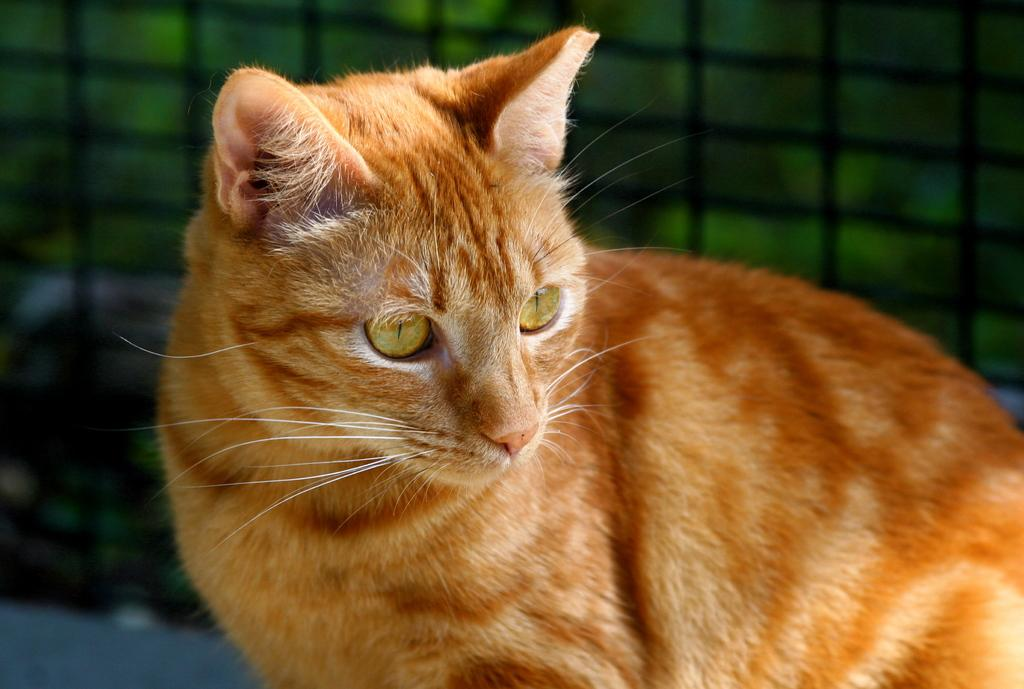What type of animal is in the image? There is a cat in the image. Can you describe the color of the cat? The cat has a cream and brown color. How would you describe the quality of the image's background? The image is blurry in the background. What type of plate is the cat using to measure its breath in the image? There is no plate or measurement of breath in the image; it only features a cat with a cream and brown color. 